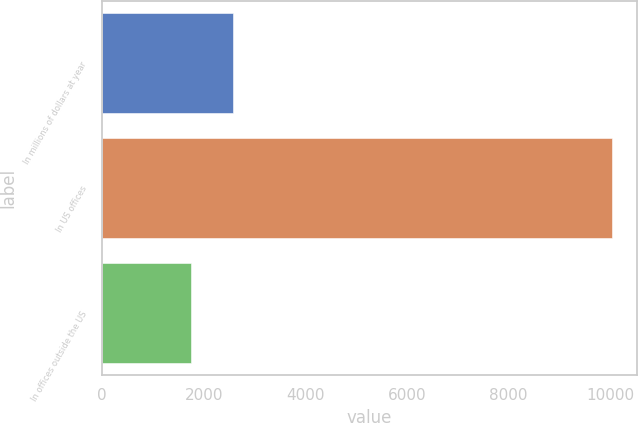Convert chart to OTSL. <chart><loc_0><loc_0><loc_500><loc_500><bar_chart><fcel>In millions of dollars at year<fcel>In US offices<fcel>In offices outside the US<nl><fcel>2582.6<fcel>10031<fcel>1755<nl></chart> 